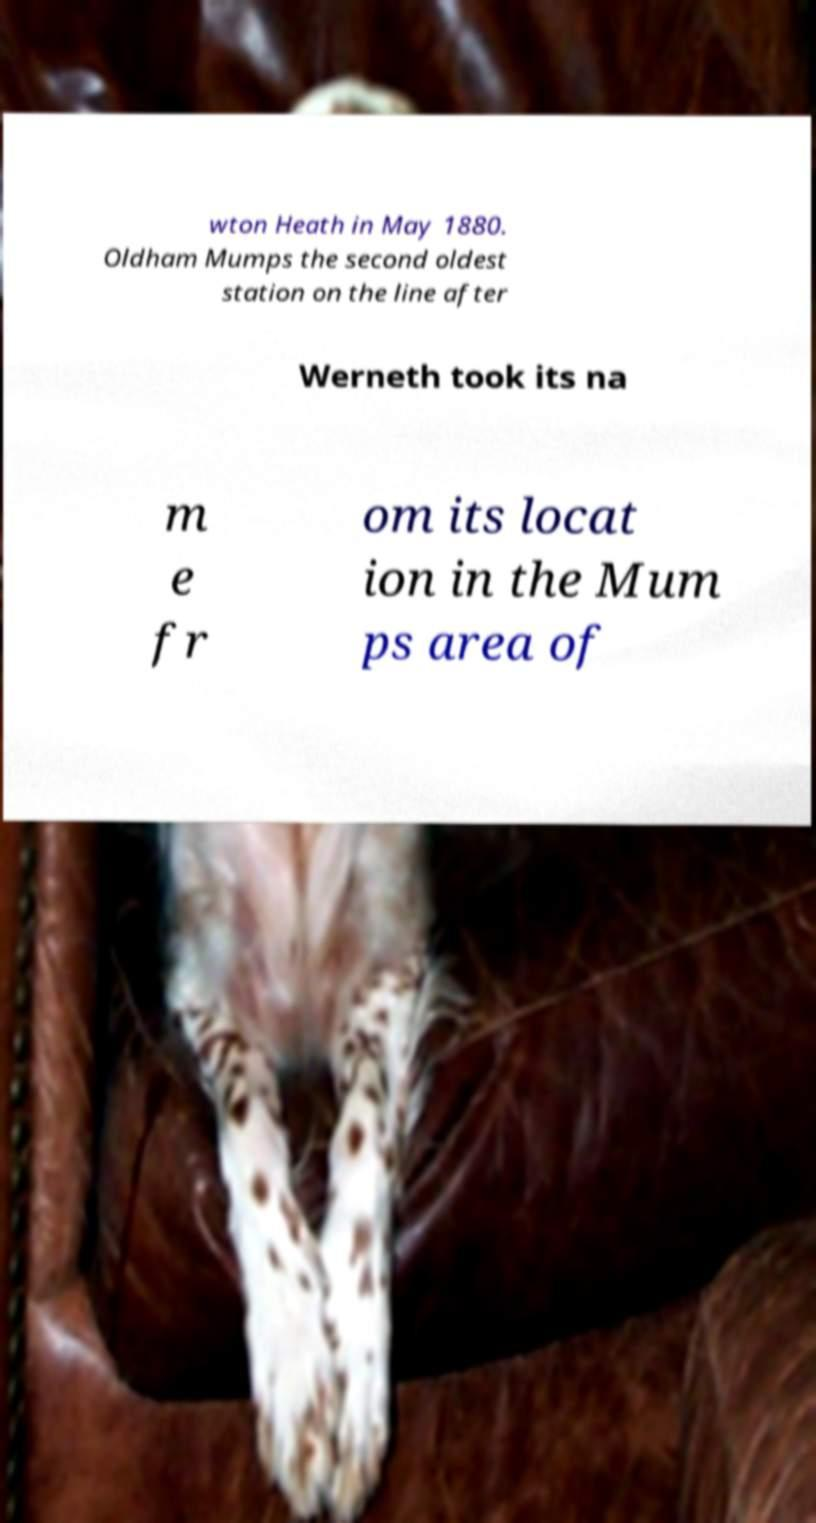Can you read and provide the text displayed in the image?This photo seems to have some interesting text. Can you extract and type it out for me? wton Heath in May 1880. Oldham Mumps the second oldest station on the line after Werneth took its na m e fr om its locat ion in the Mum ps area of 